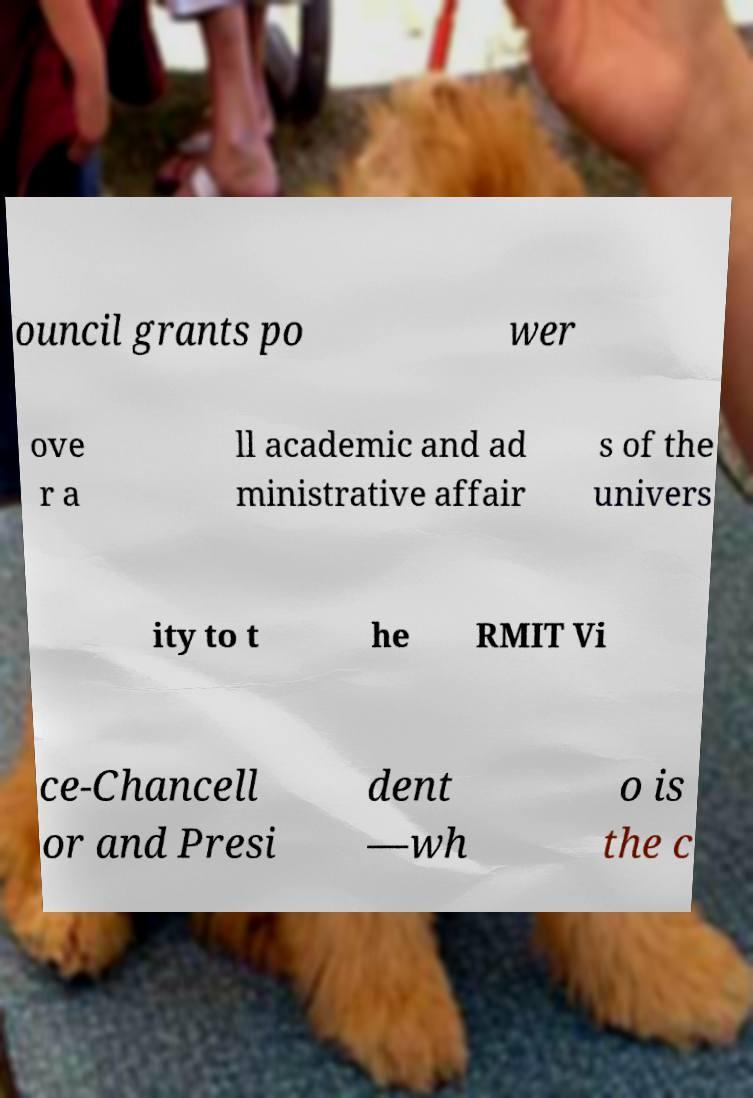Could you extract and type out the text from this image? ouncil grants po wer ove r a ll academic and ad ministrative affair s of the univers ity to t he RMIT Vi ce-Chancell or and Presi dent —wh o is the c 